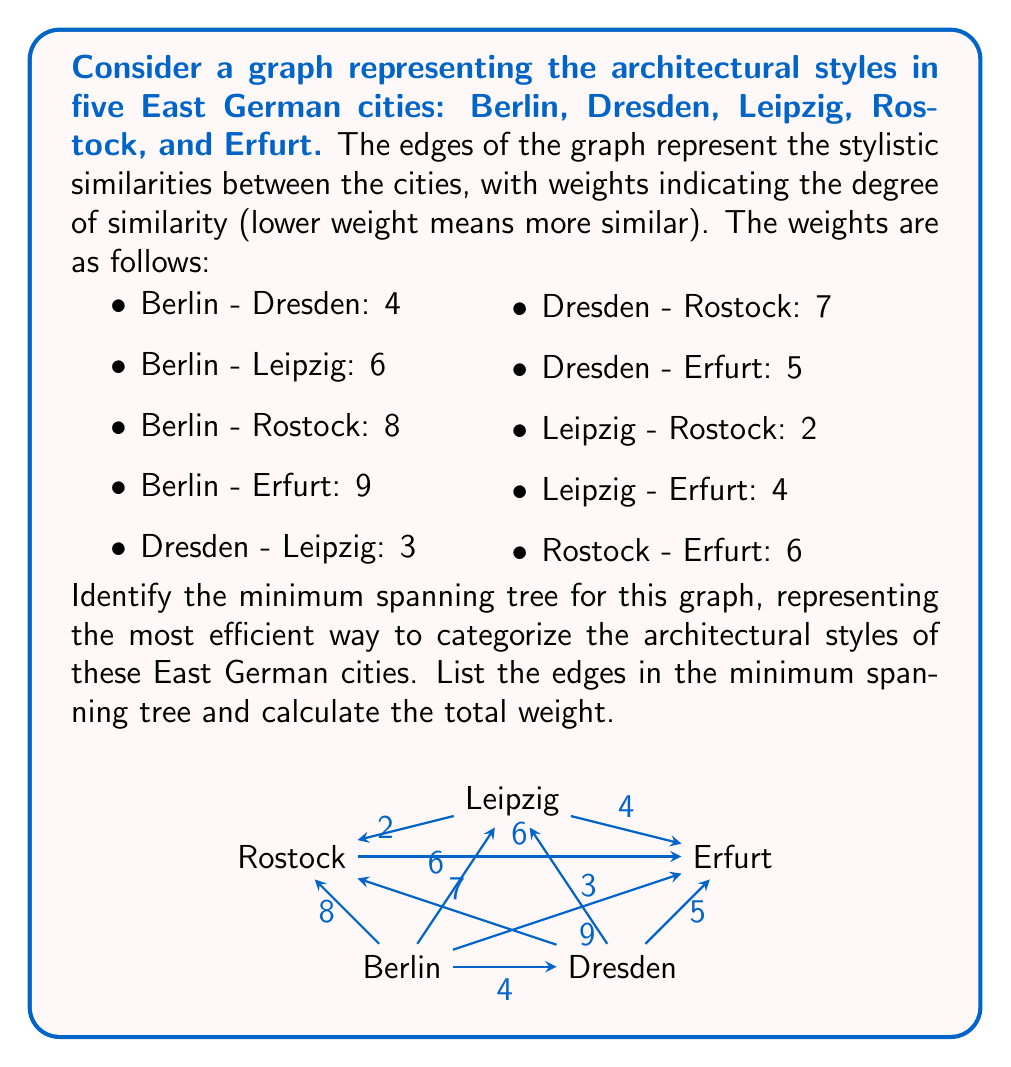Give your solution to this math problem. To find the minimum spanning tree, we can use Kruskal's algorithm, which selects edges in order of increasing weight, avoiding any edges that would create a cycle. Let's apply this algorithm step by step:

1. Sort the edges by weight:
   Leipzig - Rostock: 2
   Dresden - Leipzig: 3
   Berlin - Dresden: 4
   Leipzig - Erfurt: 4
   Dresden - Erfurt: 5
   Berlin - Leipzig: 6
   Rostock - Erfurt: 6
   Dresden - Rostock: 7
   Berlin - Rostock: 8
   Berlin - Erfurt: 9

2. Start selecting edges:
   a) Leipzig - Rostock: 2 (selected)
   b) Dresden - Leipzig: 3 (selected)
   c) Berlin - Dresden: 4 (selected)
   d) Leipzig - Erfurt: 4 (selected)

At this point, we have connected all five cities without creating any cycles, so we have our minimum spanning tree.

The selected edges are:
1. Leipzig - Rostock (2)
2. Dresden - Leipzig (3)
3. Berlin - Dresden (4)
4. Leipzig - Erfurt (4)

The total weight of the minimum spanning tree is the sum of these edge weights:
$$2 + 3 + 4 + 4 = 13$$

This minimum spanning tree represents the most efficient way to categorize the architectural styles of these East German cities, minimizing the total "distance" between styles while ensuring all cities are connected.
Answer: The minimum spanning tree consists of the following edges:
1. Leipzig - Rostock
2. Dresden - Leipzig
3. Berlin - Dresden
4. Leipzig - Erfurt

The total weight of the minimum spanning tree is 13. 